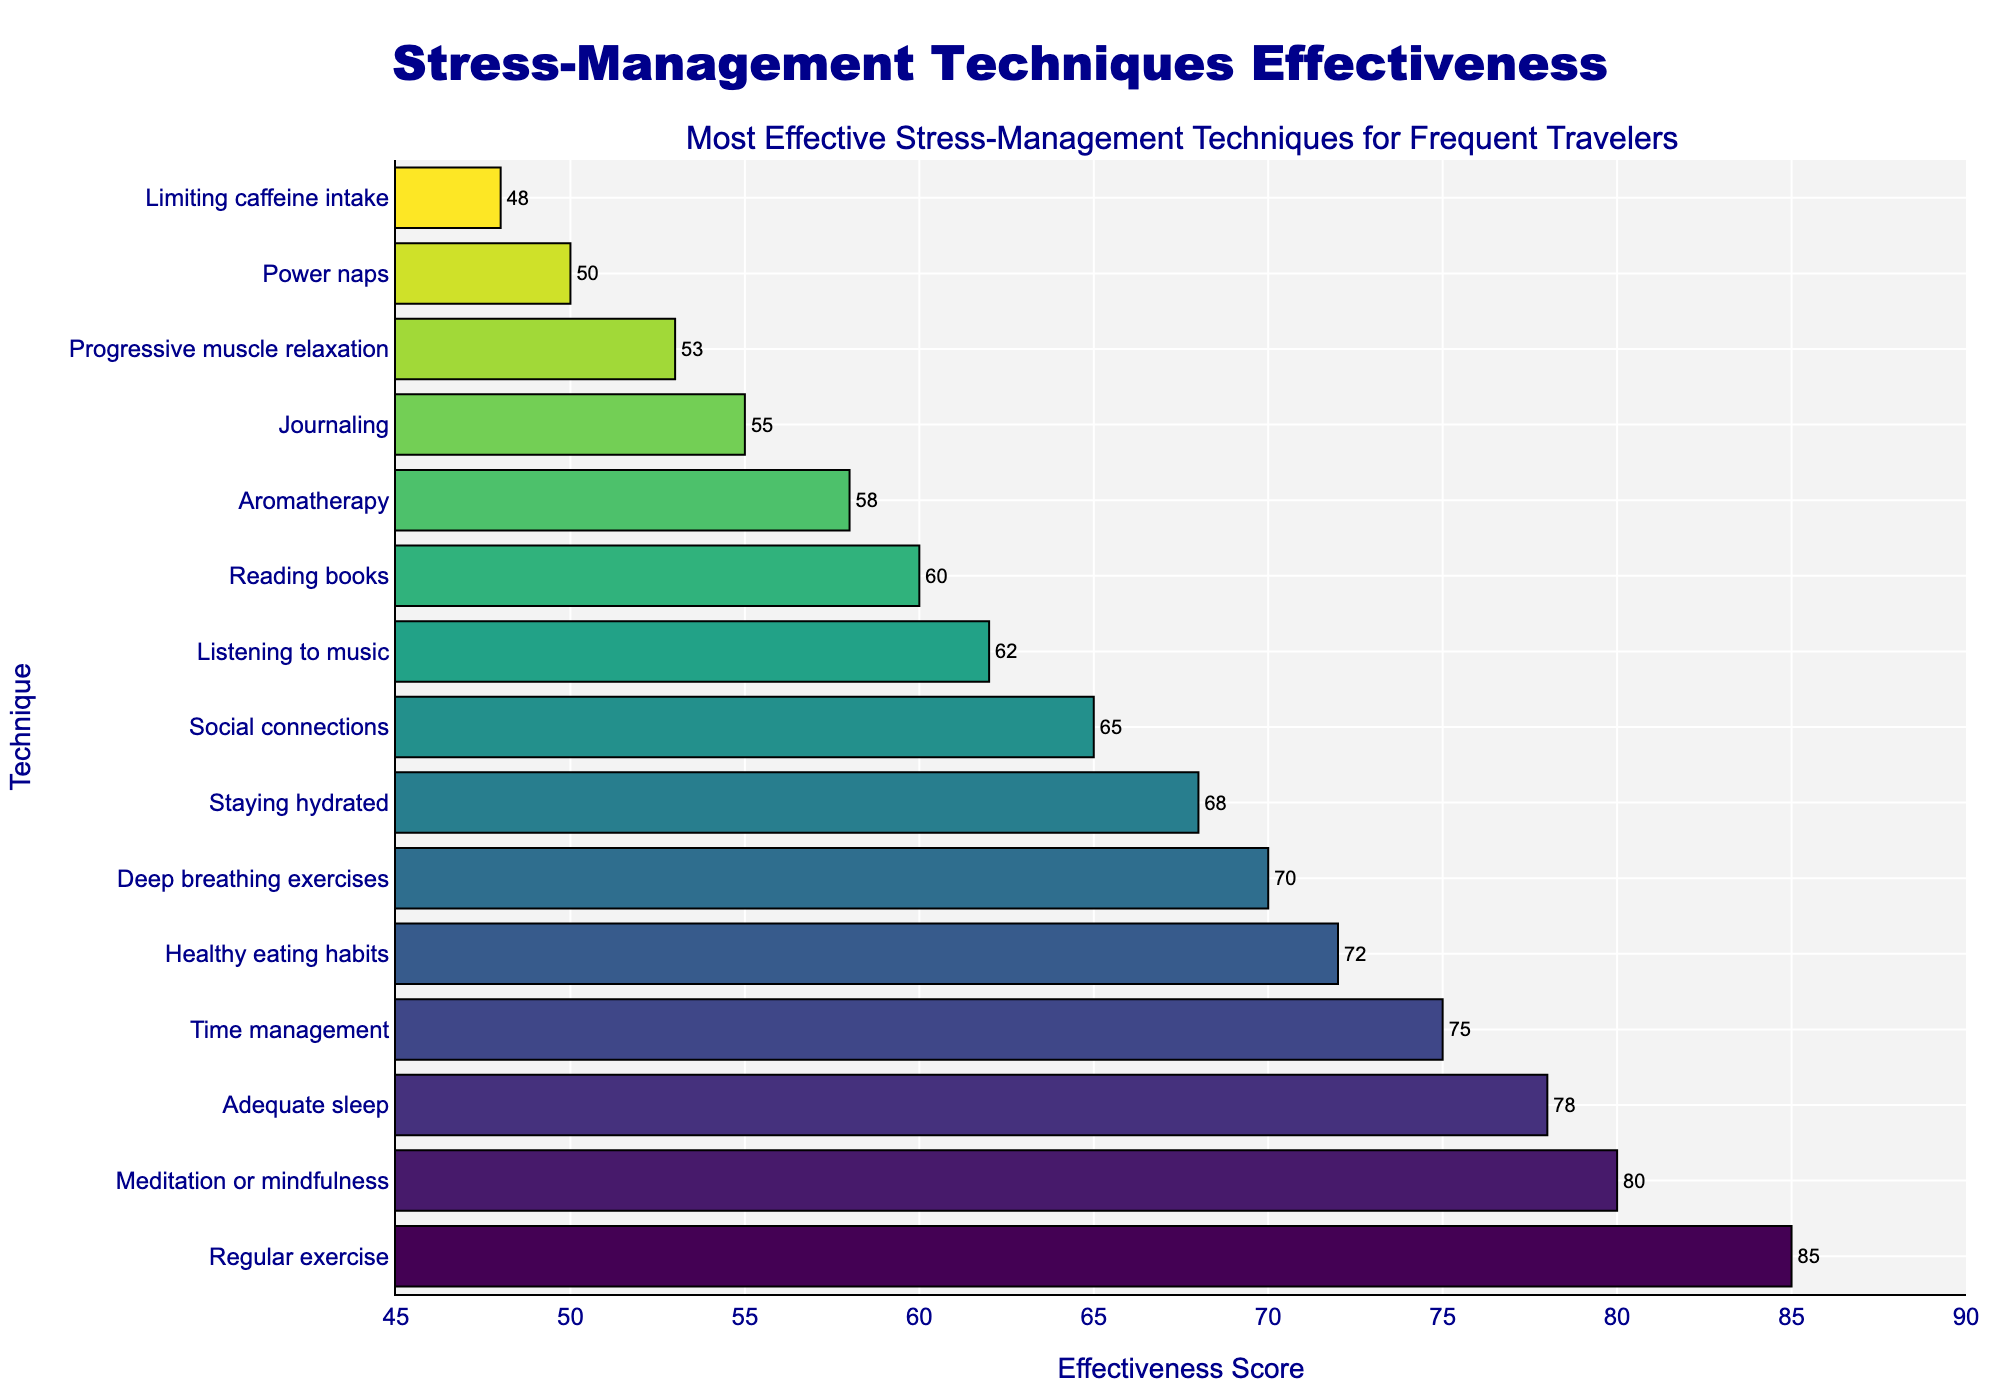Which technique is rated as the most effective for stress management? Identify the bar with the highest effectiveness score. It is the first bar after sorting in descending order.
Answer: Regular exercise Which technique has the lowest effectiveness score? Identify the bar with the lowest effectiveness score. It is the last bar after sorting.
Answer: Limiting caffeine intake How much more effective is regular exercise compared to listening to music? Locate the effectiveness scores for regular exercise and listening to music. Calculate the difference: 85 - 62.
Answer: 23 What is the median effectiveness score of these techniques? Sort the effectiveness scores and find the middle value. There are 15 techniques, so the median is the 8th value: 68.
Answer: 68 Which techniques have effectiveness scores greater than 70? Identify the bars with effectiveness scores above 70: Regular exercise, Meditation or mindfulness, Adequate sleep, Time management, and Healthy eating habits.
Answer: Regular exercise, Meditation or mindfulness, Adequate sleep, Time management, Healthy eating habits What is the average effectiveness score of the top 3 techniques? Sum the effectiveness scores of the top 3 techniques: 85 (Regular exercise) + 80 (Meditation or mindfulness) + 78 (Adequate sleep) = 243. Then divide by 3: 243/3.
Answer: 81 What is the difference in effectiveness between healthy eating habits and journaling? Identify the effectiveness scores of healthy eating habits and journaling. Calculate the difference: 72 - 55.
Answer: 17 How many techniques have effectiveness scores between 50 and 75? Count the bars with scores within the given range: Deep breathing exercises, Staying hydrated, Social connections, and Listening to music, Reading books, Aromatherapy, and Journaling.
Answer: 7 Which techniques have the same effectiveness score or close to it (within 2 points)? Look for techniques with similar scores. Healthy eating habits (72) and Deep breathing exercises (70) are close with a difference of 2 points.
Answer: Healthy eating habits, Deep breathing exercises 